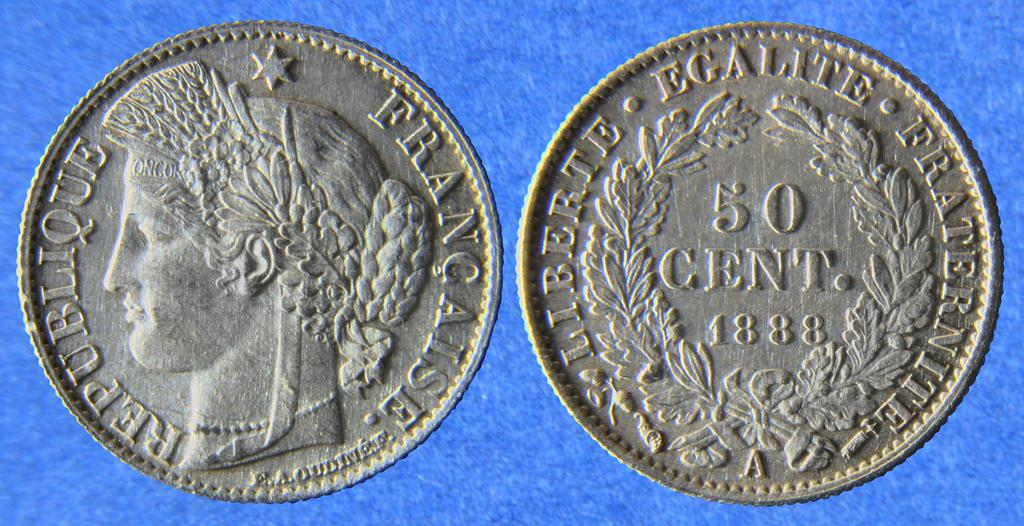<image>
Relay a brief, clear account of the picture shown. The front and back of a Republique of France 50 cent coint from 1888 is displayed. 